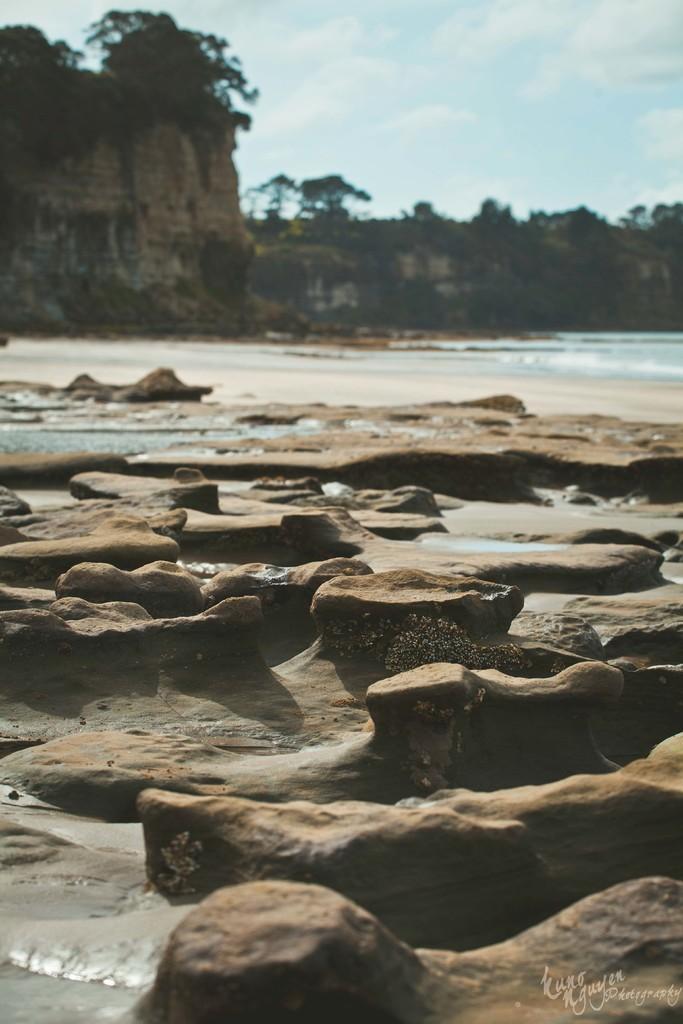Could you give a brief overview of what you see in this image? In this picture I can see few rocks and water and I can see trees and a blue cloudy sky. 